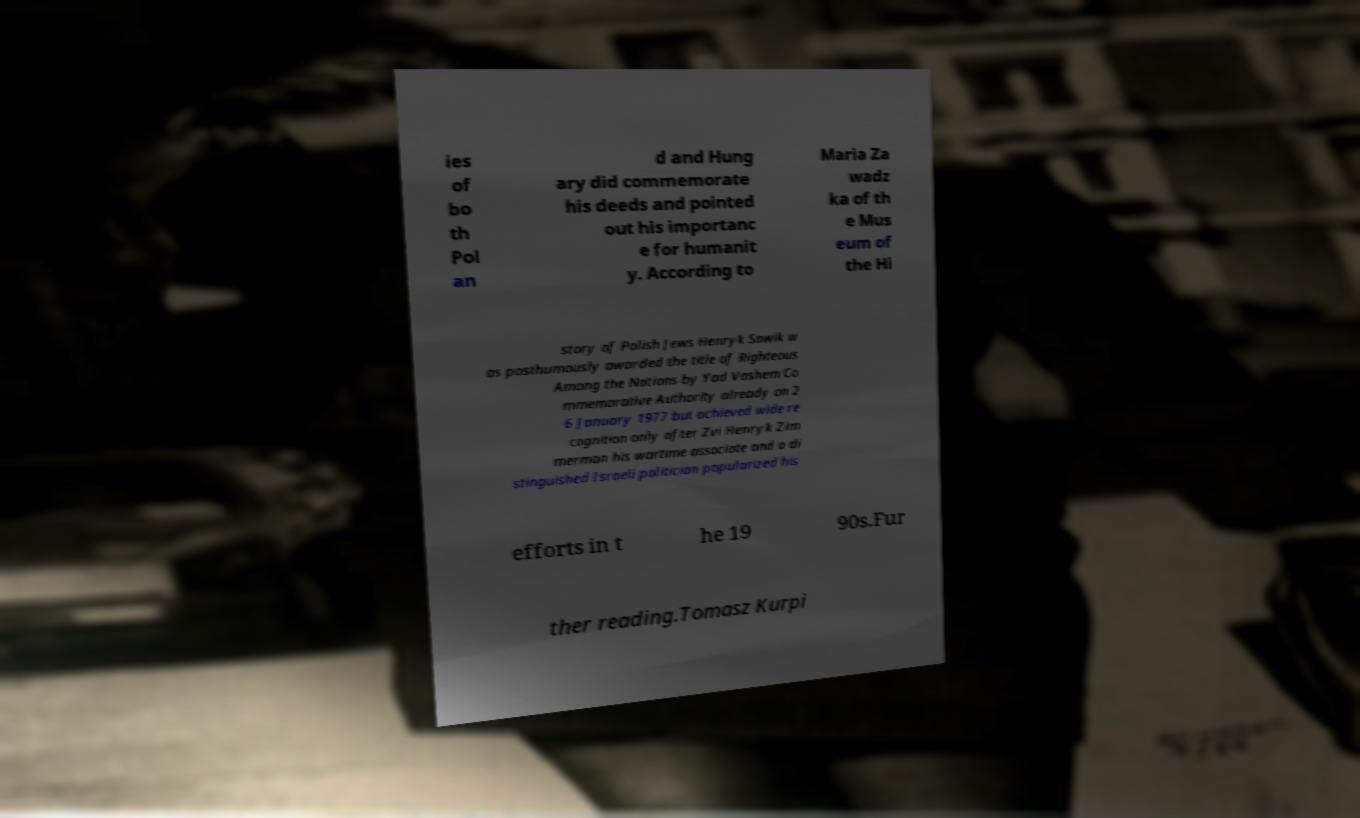Could you extract and type out the text from this image? ies of bo th Pol an d and Hung ary did commemorate his deeds and pointed out his importanc e for humanit y. According to Maria Za wadz ka of th e Mus eum of the Hi story of Polish Jews Henryk Sawik w as posthumously awarded the title of Righteous Among the Nations by Yad Vashem Co mmemorative Authority already on 2 6 January 1977 but achieved wide re cognition only after Zvi Henryk Zim merman his wartime associate and a di stinguished Israeli politician popularized his efforts in t he 19 90s.Fur ther reading.Tomasz Kurpi 